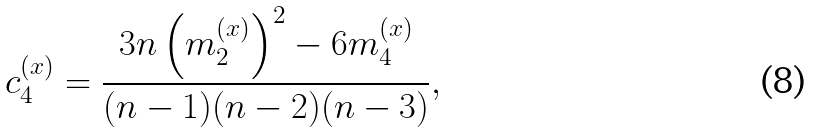Convert formula to latex. <formula><loc_0><loc_0><loc_500><loc_500>c _ { 4 } ^ { ( x ) } = \frac { 3 n \left ( m _ { 2 } ^ { ( x ) } \right ) ^ { 2 } - 6 m _ { 4 } ^ { ( x ) } } { ( n - 1 ) ( n - 2 ) ( n - 3 ) } ,</formula> 